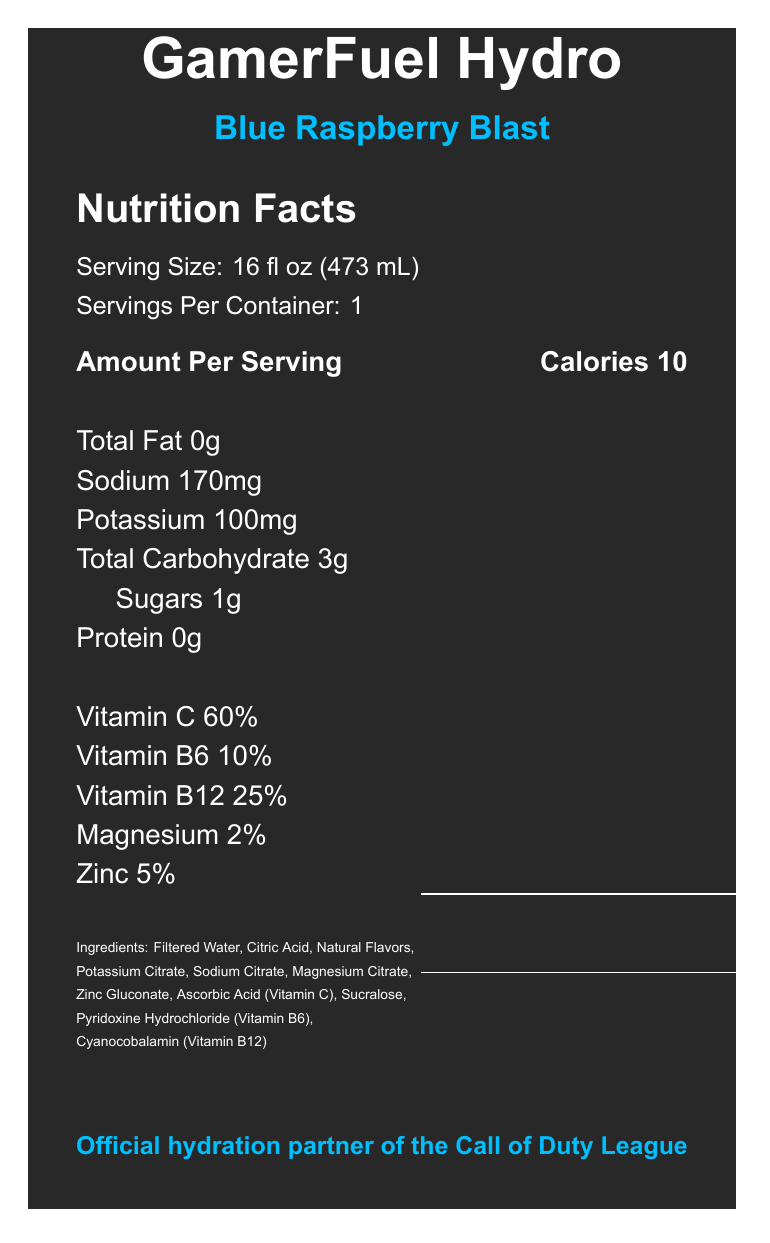what is the total calorie count per serving of GamerFuel Hydro? The document states that the calories per serving are 10.
Answer: 10 what is the serving size of GamerFuel Hydro? The serving size is explicitly mentioned as 16 fl oz (473 mL).
Answer: 16 fl oz (473 mL) how much sodium is in one serving of GamerFuel Hydro? The amount of sodium per serving is listed as 170mg.
Answer: 170mg how many grams of sugars are present in one serving? The sugars content is noted as 1g.
Answer: 1g Does GamerFuel Hydro contain any caffeine? The document clearly states that the caffeine content is 0.
Answer: No Which vitamin has the highest percentage daily value in GamerFuel Hydro? A. Vitamin C B. Vitamin B6 C. Vitamin B12 D. Magnesium Vitamin C has the highest percentage daily value at 60%, as shown in the document.
Answer: A. Vitamin C How much Vitamin B12 does one serving of GamerFuel Hydro provide? A. 10% B. 25% C. 2% D. 5% According to the document, Vitamin B12 is listed with a 25% daily value.
Answer: B. 25% Does GamerFuel Hydro include artificial flavors? The ingredients list specifies "Natural Flavors," indicating there are no artificial flavors.
Answer: No Summarize the primary purpose of GamerFuel Hydro. The summary describes the key features and benefits of the product as mentioned in the document, including its purpose for hydration, its low-calorie and caffeine-free nature, and its endorsement by the Call of Duty League.
Answer: GamerFuel Hydro is a low-calorie, caffeine-free electrolyte drink designed to support hydration and energy metabolism during long gaming sessions. It contains essential vitamins and minerals and is endorsed by the Call of Duty League. what is the flavor of GamerFuel Hydro? The document specifies that the flavor is Blue Raspberry Blast.
Answer: Blue Raspberry Blast What is the storage instruction after opening GamerFuel Hydro? The storage instructions are explicitly mentioned as keeping the drink refrigerated after opening and consuming it within 24 hours.
Answer: Keep refrigerated after opening. Consume within 24 hours of opening. What percentage of Magnesium does GamerFuel Hydro provide per serving? The percentage of Magnesium per serving is listed as 2%.
Answer: 2% Which of the following is not listed as an ingredient in GamerFuel Hydro? A. Ascorbic Acid B. Potassium Citrate C. Stevia D. Cyanocobalamin The ingredient list mentions Ascorbic Acid, Potassium Citrate, and Cyanocobalamin, but not Stevia.
Answer: C. Stevia Does GamerFuel Hydro contain protein? The document lists protein content as 0g, indicating there is no protein in the drink.
Answer: No How many servings are in one container of GamerFuel Hydro? The document specifies that there is 1 serving per container.
Answer: 1 What is the official endorsement mentioned in the document? The document states that GamerFuel Hydro is the official hydration partner of the Call of Duty League.
Answer: Official hydration partner of the Call of Duty League Can you determine the manufacturing location of GamerFuel Hydro from the document? The document does not provide any information about the manufacturing location, so it cannot be determined from the given details.
Answer: Not enough information 